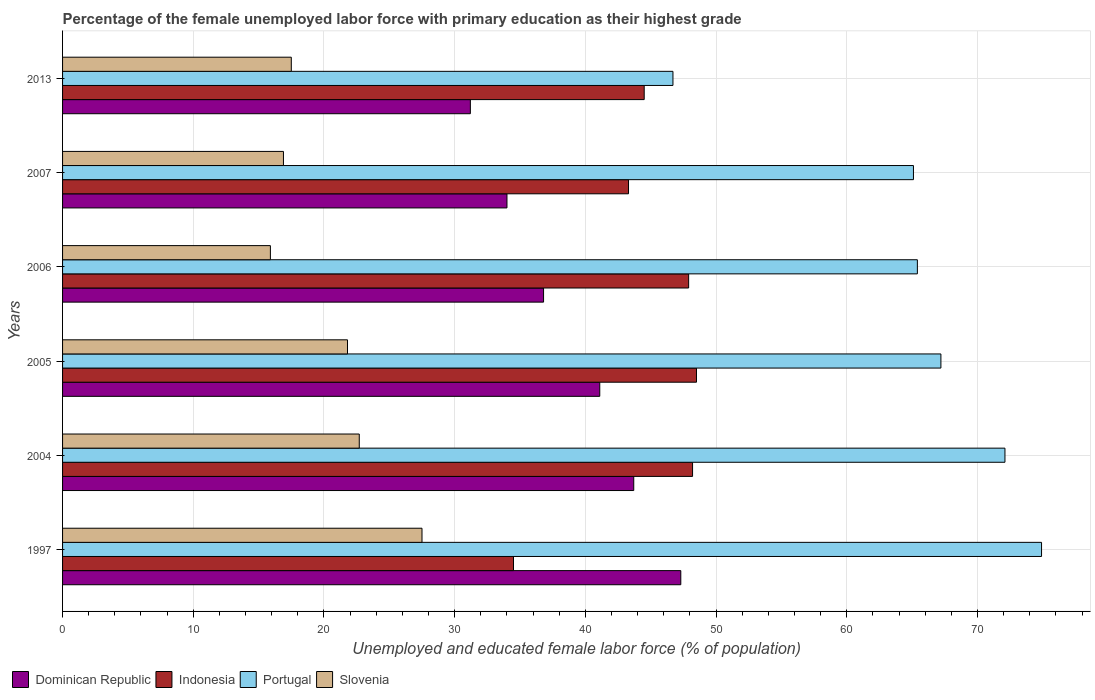How many different coloured bars are there?
Make the answer very short. 4. How many groups of bars are there?
Give a very brief answer. 6. Are the number of bars per tick equal to the number of legend labels?
Provide a short and direct response. Yes. Are the number of bars on each tick of the Y-axis equal?
Keep it short and to the point. Yes. How many bars are there on the 3rd tick from the top?
Your response must be concise. 4. What is the label of the 3rd group of bars from the top?
Provide a short and direct response. 2006. What is the percentage of the unemployed female labor force with primary education in Indonesia in 2013?
Provide a succinct answer. 44.5. Across all years, what is the maximum percentage of the unemployed female labor force with primary education in Portugal?
Provide a short and direct response. 74.9. Across all years, what is the minimum percentage of the unemployed female labor force with primary education in Dominican Republic?
Your answer should be compact. 31.2. In which year was the percentage of the unemployed female labor force with primary education in Dominican Republic maximum?
Provide a succinct answer. 1997. What is the total percentage of the unemployed female labor force with primary education in Dominican Republic in the graph?
Give a very brief answer. 234.1. What is the difference between the percentage of the unemployed female labor force with primary education in Slovenia in 2004 and that in 2005?
Give a very brief answer. 0.9. What is the difference between the percentage of the unemployed female labor force with primary education in Dominican Republic in 2013 and the percentage of the unemployed female labor force with primary education in Slovenia in 2007?
Provide a short and direct response. 14.3. What is the average percentage of the unemployed female labor force with primary education in Dominican Republic per year?
Your answer should be very brief. 39.02. In the year 2006, what is the difference between the percentage of the unemployed female labor force with primary education in Dominican Republic and percentage of the unemployed female labor force with primary education in Indonesia?
Provide a short and direct response. -11.1. What is the ratio of the percentage of the unemployed female labor force with primary education in Portugal in 2004 to that in 2013?
Provide a short and direct response. 1.54. Is the difference between the percentage of the unemployed female labor force with primary education in Dominican Republic in 2007 and 2013 greater than the difference between the percentage of the unemployed female labor force with primary education in Indonesia in 2007 and 2013?
Provide a short and direct response. Yes. What is the difference between the highest and the second highest percentage of the unemployed female labor force with primary education in Dominican Republic?
Your answer should be compact. 3.6. What is the difference between the highest and the lowest percentage of the unemployed female labor force with primary education in Dominican Republic?
Your answer should be compact. 16.1. In how many years, is the percentage of the unemployed female labor force with primary education in Indonesia greater than the average percentage of the unemployed female labor force with primary education in Indonesia taken over all years?
Make the answer very short. 4. What does the 2nd bar from the top in 1997 represents?
Provide a succinct answer. Portugal. Is it the case that in every year, the sum of the percentage of the unemployed female labor force with primary education in Dominican Republic and percentage of the unemployed female labor force with primary education in Portugal is greater than the percentage of the unemployed female labor force with primary education in Slovenia?
Your answer should be compact. Yes. How many bars are there?
Keep it short and to the point. 24. How many years are there in the graph?
Keep it short and to the point. 6. Are the values on the major ticks of X-axis written in scientific E-notation?
Offer a terse response. No. Does the graph contain grids?
Your response must be concise. Yes. How are the legend labels stacked?
Your answer should be very brief. Horizontal. What is the title of the graph?
Provide a succinct answer. Percentage of the female unemployed labor force with primary education as their highest grade. What is the label or title of the X-axis?
Offer a terse response. Unemployed and educated female labor force (% of population). What is the Unemployed and educated female labor force (% of population) in Dominican Republic in 1997?
Offer a terse response. 47.3. What is the Unemployed and educated female labor force (% of population) in Indonesia in 1997?
Provide a succinct answer. 34.5. What is the Unemployed and educated female labor force (% of population) of Portugal in 1997?
Your answer should be very brief. 74.9. What is the Unemployed and educated female labor force (% of population) of Dominican Republic in 2004?
Make the answer very short. 43.7. What is the Unemployed and educated female labor force (% of population) in Indonesia in 2004?
Offer a terse response. 48.2. What is the Unemployed and educated female labor force (% of population) in Portugal in 2004?
Offer a very short reply. 72.1. What is the Unemployed and educated female labor force (% of population) in Slovenia in 2004?
Your response must be concise. 22.7. What is the Unemployed and educated female labor force (% of population) of Dominican Republic in 2005?
Make the answer very short. 41.1. What is the Unemployed and educated female labor force (% of population) of Indonesia in 2005?
Give a very brief answer. 48.5. What is the Unemployed and educated female labor force (% of population) of Portugal in 2005?
Make the answer very short. 67.2. What is the Unemployed and educated female labor force (% of population) in Slovenia in 2005?
Give a very brief answer. 21.8. What is the Unemployed and educated female labor force (% of population) in Dominican Republic in 2006?
Provide a succinct answer. 36.8. What is the Unemployed and educated female labor force (% of population) of Indonesia in 2006?
Offer a very short reply. 47.9. What is the Unemployed and educated female labor force (% of population) of Portugal in 2006?
Provide a succinct answer. 65.4. What is the Unemployed and educated female labor force (% of population) in Slovenia in 2006?
Provide a succinct answer. 15.9. What is the Unemployed and educated female labor force (% of population) in Indonesia in 2007?
Ensure brevity in your answer.  43.3. What is the Unemployed and educated female labor force (% of population) in Portugal in 2007?
Make the answer very short. 65.1. What is the Unemployed and educated female labor force (% of population) in Slovenia in 2007?
Offer a very short reply. 16.9. What is the Unemployed and educated female labor force (% of population) of Dominican Republic in 2013?
Your answer should be very brief. 31.2. What is the Unemployed and educated female labor force (% of population) in Indonesia in 2013?
Your answer should be very brief. 44.5. What is the Unemployed and educated female labor force (% of population) of Portugal in 2013?
Keep it short and to the point. 46.7. Across all years, what is the maximum Unemployed and educated female labor force (% of population) of Dominican Republic?
Make the answer very short. 47.3. Across all years, what is the maximum Unemployed and educated female labor force (% of population) of Indonesia?
Your answer should be very brief. 48.5. Across all years, what is the maximum Unemployed and educated female labor force (% of population) in Portugal?
Provide a succinct answer. 74.9. Across all years, what is the maximum Unemployed and educated female labor force (% of population) in Slovenia?
Your answer should be very brief. 27.5. Across all years, what is the minimum Unemployed and educated female labor force (% of population) of Dominican Republic?
Offer a very short reply. 31.2. Across all years, what is the minimum Unemployed and educated female labor force (% of population) of Indonesia?
Offer a very short reply. 34.5. Across all years, what is the minimum Unemployed and educated female labor force (% of population) in Portugal?
Make the answer very short. 46.7. Across all years, what is the minimum Unemployed and educated female labor force (% of population) of Slovenia?
Ensure brevity in your answer.  15.9. What is the total Unemployed and educated female labor force (% of population) of Dominican Republic in the graph?
Provide a succinct answer. 234.1. What is the total Unemployed and educated female labor force (% of population) in Indonesia in the graph?
Your answer should be compact. 266.9. What is the total Unemployed and educated female labor force (% of population) in Portugal in the graph?
Provide a succinct answer. 391.4. What is the total Unemployed and educated female labor force (% of population) in Slovenia in the graph?
Provide a short and direct response. 122.3. What is the difference between the Unemployed and educated female labor force (% of population) in Indonesia in 1997 and that in 2004?
Your answer should be compact. -13.7. What is the difference between the Unemployed and educated female labor force (% of population) in Portugal in 1997 and that in 2004?
Provide a succinct answer. 2.8. What is the difference between the Unemployed and educated female labor force (% of population) in Slovenia in 1997 and that in 2004?
Your answer should be very brief. 4.8. What is the difference between the Unemployed and educated female labor force (% of population) in Dominican Republic in 1997 and that in 2005?
Give a very brief answer. 6.2. What is the difference between the Unemployed and educated female labor force (% of population) in Indonesia in 1997 and that in 2005?
Your response must be concise. -14. What is the difference between the Unemployed and educated female labor force (% of population) of Portugal in 1997 and that in 2005?
Provide a succinct answer. 7.7. What is the difference between the Unemployed and educated female labor force (% of population) in Slovenia in 1997 and that in 2005?
Ensure brevity in your answer.  5.7. What is the difference between the Unemployed and educated female labor force (% of population) of Indonesia in 1997 and that in 2006?
Make the answer very short. -13.4. What is the difference between the Unemployed and educated female labor force (% of population) in Portugal in 1997 and that in 2006?
Give a very brief answer. 9.5. What is the difference between the Unemployed and educated female labor force (% of population) in Dominican Republic in 1997 and that in 2007?
Offer a terse response. 13.3. What is the difference between the Unemployed and educated female labor force (% of population) of Indonesia in 1997 and that in 2013?
Make the answer very short. -10. What is the difference between the Unemployed and educated female labor force (% of population) of Portugal in 1997 and that in 2013?
Make the answer very short. 28.2. What is the difference between the Unemployed and educated female labor force (% of population) in Slovenia in 1997 and that in 2013?
Your response must be concise. 10. What is the difference between the Unemployed and educated female labor force (% of population) in Dominican Republic in 2004 and that in 2005?
Offer a very short reply. 2.6. What is the difference between the Unemployed and educated female labor force (% of population) in Indonesia in 2004 and that in 2005?
Your answer should be compact. -0.3. What is the difference between the Unemployed and educated female labor force (% of population) in Slovenia in 2004 and that in 2005?
Keep it short and to the point. 0.9. What is the difference between the Unemployed and educated female labor force (% of population) of Dominican Republic in 2004 and that in 2006?
Offer a terse response. 6.9. What is the difference between the Unemployed and educated female labor force (% of population) of Indonesia in 2004 and that in 2006?
Give a very brief answer. 0.3. What is the difference between the Unemployed and educated female labor force (% of population) of Portugal in 2004 and that in 2006?
Offer a very short reply. 6.7. What is the difference between the Unemployed and educated female labor force (% of population) of Slovenia in 2004 and that in 2006?
Ensure brevity in your answer.  6.8. What is the difference between the Unemployed and educated female labor force (% of population) of Dominican Republic in 2004 and that in 2007?
Provide a short and direct response. 9.7. What is the difference between the Unemployed and educated female labor force (% of population) of Dominican Republic in 2004 and that in 2013?
Offer a terse response. 12.5. What is the difference between the Unemployed and educated female labor force (% of population) of Portugal in 2004 and that in 2013?
Your answer should be compact. 25.4. What is the difference between the Unemployed and educated female labor force (% of population) of Slovenia in 2004 and that in 2013?
Provide a short and direct response. 5.2. What is the difference between the Unemployed and educated female labor force (% of population) of Dominican Republic in 2005 and that in 2006?
Your response must be concise. 4.3. What is the difference between the Unemployed and educated female labor force (% of population) of Portugal in 2005 and that in 2006?
Ensure brevity in your answer.  1.8. What is the difference between the Unemployed and educated female labor force (% of population) in Slovenia in 2005 and that in 2006?
Keep it short and to the point. 5.9. What is the difference between the Unemployed and educated female labor force (% of population) in Indonesia in 2005 and that in 2007?
Offer a very short reply. 5.2. What is the difference between the Unemployed and educated female labor force (% of population) in Dominican Republic in 2005 and that in 2013?
Your response must be concise. 9.9. What is the difference between the Unemployed and educated female labor force (% of population) of Indonesia in 2005 and that in 2013?
Offer a very short reply. 4. What is the difference between the Unemployed and educated female labor force (% of population) in Slovenia in 2005 and that in 2013?
Offer a very short reply. 4.3. What is the difference between the Unemployed and educated female labor force (% of population) of Dominican Republic in 2006 and that in 2007?
Offer a terse response. 2.8. What is the difference between the Unemployed and educated female labor force (% of population) of Portugal in 2006 and that in 2007?
Make the answer very short. 0.3. What is the difference between the Unemployed and educated female labor force (% of population) in Slovenia in 2006 and that in 2013?
Keep it short and to the point. -1.6. What is the difference between the Unemployed and educated female labor force (% of population) in Dominican Republic in 2007 and that in 2013?
Offer a very short reply. 2.8. What is the difference between the Unemployed and educated female labor force (% of population) in Portugal in 2007 and that in 2013?
Give a very brief answer. 18.4. What is the difference between the Unemployed and educated female labor force (% of population) of Dominican Republic in 1997 and the Unemployed and educated female labor force (% of population) of Indonesia in 2004?
Your response must be concise. -0.9. What is the difference between the Unemployed and educated female labor force (% of population) of Dominican Republic in 1997 and the Unemployed and educated female labor force (% of population) of Portugal in 2004?
Give a very brief answer. -24.8. What is the difference between the Unemployed and educated female labor force (% of population) of Dominican Republic in 1997 and the Unemployed and educated female labor force (% of population) of Slovenia in 2004?
Make the answer very short. 24.6. What is the difference between the Unemployed and educated female labor force (% of population) in Indonesia in 1997 and the Unemployed and educated female labor force (% of population) in Portugal in 2004?
Offer a very short reply. -37.6. What is the difference between the Unemployed and educated female labor force (% of population) in Portugal in 1997 and the Unemployed and educated female labor force (% of population) in Slovenia in 2004?
Your answer should be very brief. 52.2. What is the difference between the Unemployed and educated female labor force (% of population) of Dominican Republic in 1997 and the Unemployed and educated female labor force (% of population) of Portugal in 2005?
Make the answer very short. -19.9. What is the difference between the Unemployed and educated female labor force (% of population) of Dominican Republic in 1997 and the Unemployed and educated female labor force (% of population) of Slovenia in 2005?
Give a very brief answer. 25.5. What is the difference between the Unemployed and educated female labor force (% of population) of Indonesia in 1997 and the Unemployed and educated female labor force (% of population) of Portugal in 2005?
Keep it short and to the point. -32.7. What is the difference between the Unemployed and educated female labor force (% of population) of Portugal in 1997 and the Unemployed and educated female labor force (% of population) of Slovenia in 2005?
Offer a terse response. 53.1. What is the difference between the Unemployed and educated female labor force (% of population) of Dominican Republic in 1997 and the Unemployed and educated female labor force (% of population) of Portugal in 2006?
Your answer should be compact. -18.1. What is the difference between the Unemployed and educated female labor force (% of population) of Dominican Republic in 1997 and the Unemployed and educated female labor force (% of population) of Slovenia in 2006?
Make the answer very short. 31.4. What is the difference between the Unemployed and educated female labor force (% of population) in Indonesia in 1997 and the Unemployed and educated female labor force (% of population) in Portugal in 2006?
Your response must be concise. -30.9. What is the difference between the Unemployed and educated female labor force (% of population) in Portugal in 1997 and the Unemployed and educated female labor force (% of population) in Slovenia in 2006?
Offer a very short reply. 59. What is the difference between the Unemployed and educated female labor force (% of population) in Dominican Republic in 1997 and the Unemployed and educated female labor force (% of population) in Portugal in 2007?
Make the answer very short. -17.8. What is the difference between the Unemployed and educated female labor force (% of population) in Dominican Republic in 1997 and the Unemployed and educated female labor force (% of population) in Slovenia in 2007?
Keep it short and to the point. 30.4. What is the difference between the Unemployed and educated female labor force (% of population) of Indonesia in 1997 and the Unemployed and educated female labor force (% of population) of Portugal in 2007?
Make the answer very short. -30.6. What is the difference between the Unemployed and educated female labor force (% of population) in Dominican Republic in 1997 and the Unemployed and educated female labor force (% of population) in Indonesia in 2013?
Offer a very short reply. 2.8. What is the difference between the Unemployed and educated female labor force (% of population) in Dominican Republic in 1997 and the Unemployed and educated female labor force (% of population) in Slovenia in 2013?
Offer a very short reply. 29.8. What is the difference between the Unemployed and educated female labor force (% of population) in Indonesia in 1997 and the Unemployed and educated female labor force (% of population) in Portugal in 2013?
Your answer should be compact. -12.2. What is the difference between the Unemployed and educated female labor force (% of population) in Portugal in 1997 and the Unemployed and educated female labor force (% of population) in Slovenia in 2013?
Your answer should be very brief. 57.4. What is the difference between the Unemployed and educated female labor force (% of population) of Dominican Republic in 2004 and the Unemployed and educated female labor force (% of population) of Indonesia in 2005?
Keep it short and to the point. -4.8. What is the difference between the Unemployed and educated female labor force (% of population) in Dominican Republic in 2004 and the Unemployed and educated female labor force (% of population) in Portugal in 2005?
Provide a short and direct response. -23.5. What is the difference between the Unemployed and educated female labor force (% of population) in Dominican Republic in 2004 and the Unemployed and educated female labor force (% of population) in Slovenia in 2005?
Offer a very short reply. 21.9. What is the difference between the Unemployed and educated female labor force (% of population) of Indonesia in 2004 and the Unemployed and educated female labor force (% of population) of Slovenia in 2005?
Your answer should be very brief. 26.4. What is the difference between the Unemployed and educated female labor force (% of population) in Portugal in 2004 and the Unemployed and educated female labor force (% of population) in Slovenia in 2005?
Ensure brevity in your answer.  50.3. What is the difference between the Unemployed and educated female labor force (% of population) in Dominican Republic in 2004 and the Unemployed and educated female labor force (% of population) in Portugal in 2006?
Make the answer very short. -21.7. What is the difference between the Unemployed and educated female labor force (% of population) of Dominican Republic in 2004 and the Unemployed and educated female labor force (% of population) of Slovenia in 2006?
Provide a succinct answer. 27.8. What is the difference between the Unemployed and educated female labor force (% of population) in Indonesia in 2004 and the Unemployed and educated female labor force (% of population) in Portugal in 2006?
Make the answer very short. -17.2. What is the difference between the Unemployed and educated female labor force (% of population) in Indonesia in 2004 and the Unemployed and educated female labor force (% of population) in Slovenia in 2006?
Provide a short and direct response. 32.3. What is the difference between the Unemployed and educated female labor force (% of population) of Portugal in 2004 and the Unemployed and educated female labor force (% of population) of Slovenia in 2006?
Your answer should be compact. 56.2. What is the difference between the Unemployed and educated female labor force (% of population) in Dominican Republic in 2004 and the Unemployed and educated female labor force (% of population) in Portugal in 2007?
Your answer should be compact. -21.4. What is the difference between the Unemployed and educated female labor force (% of population) in Dominican Republic in 2004 and the Unemployed and educated female labor force (% of population) in Slovenia in 2007?
Your answer should be compact. 26.8. What is the difference between the Unemployed and educated female labor force (% of population) in Indonesia in 2004 and the Unemployed and educated female labor force (% of population) in Portugal in 2007?
Make the answer very short. -16.9. What is the difference between the Unemployed and educated female labor force (% of population) in Indonesia in 2004 and the Unemployed and educated female labor force (% of population) in Slovenia in 2007?
Keep it short and to the point. 31.3. What is the difference between the Unemployed and educated female labor force (% of population) of Portugal in 2004 and the Unemployed and educated female labor force (% of population) of Slovenia in 2007?
Make the answer very short. 55.2. What is the difference between the Unemployed and educated female labor force (% of population) of Dominican Republic in 2004 and the Unemployed and educated female labor force (% of population) of Slovenia in 2013?
Provide a succinct answer. 26.2. What is the difference between the Unemployed and educated female labor force (% of population) of Indonesia in 2004 and the Unemployed and educated female labor force (% of population) of Slovenia in 2013?
Make the answer very short. 30.7. What is the difference between the Unemployed and educated female labor force (% of population) in Portugal in 2004 and the Unemployed and educated female labor force (% of population) in Slovenia in 2013?
Your response must be concise. 54.6. What is the difference between the Unemployed and educated female labor force (% of population) in Dominican Republic in 2005 and the Unemployed and educated female labor force (% of population) in Indonesia in 2006?
Ensure brevity in your answer.  -6.8. What is the difference between the Unemployed and educated female labor force (% of population) in Dominican Republic in 2005 and the Unemployed and educated female labor force (% of population) in Portugal in 2006?
Offer a very short reply. -24.3. What is the difference between the Unemployed and educated female labor force (% of population) of Dominican Republic in 2005 and the Unemployed and educated female labor force (% of population) of Slovenia in 2006?
Provide a short and direct response. 25.2. What is the difference between the Unemployed and educated female labor force (% of population) of Indonesia in 2005 and the Unemployed and educated female labor force (% of population) of Portugal in 2006?
Give a very brief answer. -16.9. What is the difference between the Unemployed and educated female labor force (% of population) in Indonesia in 2005 and the Unemployed and educated female labor force (% of population) in Slovenia in 2006?
Your answer should be very brief. 32.6. What is the difference between the Unemployed and educated female labor force (% of population) in Portugal in 2005 and the Unemployed and educated female labor force (% of population) in Slovenia in 2006?
Ensure brevity in your answer.  51.3. What is the difference between the Unemployed and educated female labor force (% of population) of Dominican Republic in 2005 and the Unemployed and educated female labor force (% of population) of Portugal in 2007?
Your answer should be compact. -24. What is the difference between the Unemployed and educated female labor force (% of population) in Dominican Republic in 2005 and the Unemployed and educated female labor force (% of population) in Slovenia in 2007?
Give a very brief answer. 24.2. What is the difference between the Unemployed and educated female labor force (% of population) of Indonesia in 2005 and the Unemployed and educated female labor force (% of population) of Portugal in 2007?
Ensure brevity in your answer.  -16.6. What is the difference between the Unemployed and educated female labor force (% of population) in Indonesia in 2005 and the Unemployed and educated female labor force (% of population) in Slovenia in 2007?
Offer a very short reply. 31.6. What is the difference between the Unemployed and educated female labor force (% of population) of Portugal in 2005 and the Unemployed and educated female labor force (% of population) of Slovenia in 2007?
Give a very brief answer. 50.3. What is the difference between the Unemployed and educated female labor force (% of population) of Dominican Republic in 2005 and the Unemployed and educated female labor force (% of population) of Slovenia in 2013?
Provide a short and direct response. 23.6. What is the difference between the Unemployed and educated female labor force (% of population) of Indonesia in 2005 and the Unemployed and educated female labor force (% of population) of Portugal in 2013?
Give a very brief answer. 1.8. What is the difference between the Unemployed and educated female labor force (% of population) in Indonesia in 2005 and the Unemployed and educated female labor force (% of population) in Slovenia in 2013?
Your response must be concise. 31. What is the difference between the Unemployed and educated female labor force (% of population) of Portugal in 2005 and the Unemployed and educated female labor force (% of population) of Slovenia in 2013?
Ensure brevity in your answer.  49.7. What is the difference between the Unemployed and educated female labor force (% of population) in Dominican Republic in 2006 and the Unemployed and educated female labor force (% of population) in Portugal in 2007?
Make the answer very short. -28.3. What is the difference between the Unemployed and educated female labor force (% of population) in Indonesia in 2006 and the Unemployed and educated female labor force (% of population) in Portugal in 2007?
Make the answer very short. -17.2. What is the difference between the Unemployed and educated female labor force (% of population) in Portugal in 2006 and the Unemployed and educated female labor force (% of population) in Slovenia in 2007?
Provide a succinct answer. 48.5. What is the difference between the Unemployed and educated female labor force (% of population) of Dominican Republic in 2006 and the Unemployed and educated female labor force (% of population) of Slovenia in 2013?
Your response must be concise. 19.3. What is the difference between the Unemployed and educated female labor force (% of population) in Indonesia in 2006 and the Unemployed and educated female labor force (% of population) in Slovenia in 2013?
Give a very brief answer. 30.4. What is the difference between the Unemployed and educated female labor force (% of population) of Portugal in 2006 and the Unemployed and educated female labor force (% of population) of Slovenia in 2013?
Provide a succinct answer. 47.9. What is the difference between the Unemployed and educated female labor force (% of population) in Dominican Republic in 2007 and the Unemployed and educated female labor force (% of population) in Indonesia in 2013?
Provide a short and direct response. -10.5. What is the difference between the Unemployed and educated female labor force (% of population) of Dominican Republic in 2007 and the Unemployed and educated female labor force (% of population) of Slovenia in 2013?
Your response must be concise. 16.5. What is the difference between the Unemployed and educated female labor force (% of population) of Indonesia in 2007 and the Unemployed and educated female labor force (% of population) of Slovenia in 2013?
Make the answer very short. 25.8. What is the difference between the Unemployed and educated female labor force (% of population) of Portugal in 2007 and the Unemployed and educated female labor force (% of population) of Slovenia in 2013?
Keep it short and to the point. 47.6. What is the average Unemployed and educated female labor force (% of population) in Dominican Republic per year?
Your answer should be very brief. 39.02. What is the average Unemployed and educated female labor force (% of population) of Indonesia per year?
Give a very brief answer. 44.48. What is the average Unemployed and educated female labor force (% of population) of Portugal per year?
Offer a terse response. 65.23. What is the average Unemployed and educated female labor force (% of population) in Slovenia per year?
Your answer should be compact. 20.38. In the year 1997, what is the difference between the Unemployed and educated female labor force (% of population) of Dominican Republic and Unemployed and educated female labor force (% of population) of Portugal?
Your answer should be very brief. -27.6. In the year 1997, what is the difference between the Unemployed and educated female labor force (% of population) of Dominican Republic and Unemployed and educated female labor force (% of population) of Slovenia?
Offer a very short reply. 19.8. In the year 1997, what is the difference between the Unemployed and educated female labor force (% of population) in Indonesia and Unemployed and educated female labor force (% of population) in Portugal?
Your answer should be compact. -40.4. In the year 1997, what is the difference between the Unemployed and educated female labor force (% of population) in Portugal and Unemployed and educated female labor force (% of population) in Slovenia?
Your answer should be compact. 47.4. In the year 2004, what is the difference between the Unemployed and educated female labor force (% of population) in Dominican Republic and Unemployed and educated female labor force (% of population) in Portugal?
Offer a terse response. -28.4. In the year 2004, what is the difference between the Unemployed and educated female labor force (% of population) in Indonesia and Unemployed and educated female labor force (% of population) in Portugal?
Keep it short and to the point. -23.9. In the year 2004, what is the difference between the Unemployed and educated female labor force (% of population) of Indonesia and Unemployed and educated female labor force (% of population) of Slovenia?
Offer a terse response. 25.5. In the year 2004, what is the difference between the Unemployed and educated female labor force (% of population) in Portugal and Unemployed and educated female labor force (% of population) in Slovenia?
Provide a succinct answer. 49.4. In the year 2005, what is the difference between the Unemployed and educated female labor force (% of population) of Dominican Republic and Unemployed and educated female labor force (% of population) of Indonesia?
Make the answer very short. -7.4. In the year 2005, what is the difference between the Unemployed and educated female labor force (% of population) of Dominican Republic and Unemployed and educated female labor force (% of population) of Portugal?
Provide a short and direct response. -26.1. In the year 2005, what is the difference between the Unemployed and educated female labor force (% of population) of Dominican Republic and Unemployed and educated female labor force (% of population) of Slovenia?
Your response must be concise. 19.3. In the year 2005, what is the difference between the Unemployed and educated female labor force (% of population) of Indonesia and Unemployed and educated female labor force (% of population) of Portugal?
Give a very brief answer. -18.7. In the year 2005, what is the difference between the Unemployed and educated female labor force (% of population) in Indonesia and Unemployed and educated female labor force (% of population) in Slovenia?
Make the answer very short. 26.7. In the year 2005, what is the difference between the Unemployed and educated female labor force (% of population) of Portugal and Unemployed and educated female labor force (% of population) of Slovenia?
Provide a succinct answer. 45.4. In the year 2006, what is the difference between the Unemployed and educated female labor force (% of population) of Dominican Republic and Unemployed and educated female labor force (% of population) of Indonesia?
Keep it short and to the point. -11.1. In the year 2006, what is the difference between the Unemployed and educated female labor force (% of population) of Dominican Republic and Unemployed and educated female labor force (% of population) of Portugal?
Your answer should be compact. -28.6. In the year 2006, what is the difference between the Unemployed and educated female labor force (% of population) in Dominican Republic and Unemployed and educated female labor force (% of population) in Slovenia?
Give a very brief answer. 20.9. In the year 2006, what is the difference between the Unemployed and educated female labor force (% of population) in Indonesia and Unemployed and educated female labor force (% of population) in Portugal?
Give a very brief answer. -17.5. In the year 2006, what is the difference between the Unemployed and educated female labor force (% of population) of Indonesia and Unemployed and educated female labor force (% of population) of Slovenia?
Provide a succinct answer. 32. In the year 2006, what is the difference between the Unemployed and educated female labor force (% of population) in Portugal and Unemployed and educated female labor force (% of population) in Slovenia?
Give a very brief answer. 49.5. In the year 2007, what is the difference between the Unemployed and educated female labor force (% of population) of Dominican Republic and Unemployed and educated female labor force (% of population) of Portugal?
Ensure brevity in your answer.  -31.1. In the year 2007, what is the difference between the Unemployed and educated female labor force (% of population) of Dominican Republic and Unemployed and educated female labor force (% of population) of Slovenia?
Ensure brevity in your answer.  17.1. In the year 2007, what is the difference between the Unemployed and educated female labor force (% of population) in Indonesia and Unemployed and educated female labor force (% of population) in Portugal?
Your response must be concise. -21.8. In the year 2007, what is the difference between the Unemployed and educated female labor force (% of population) of Indonesia and Unemployed and educated female labor force (% of population) of Slovenia?
Provide a succinct answer. 26.4. In the year 2007, what is the difference between the Unemployed and educated female labor force (% of population) in Portugal and Unemployed and educated female labor force (% of population) in Slovenia?
Provide a succinct answer. 48.2. In the year 2013, what is the difference between the Unemployed and educated female labor force (% of population) of Dominican Republic and Unemployed and educated female labor force (% of population) of Portugal?
Keep it short and to the point. -15.5. In the year 2013, what is the difference between the Unemployed and educated female labor force (% of population) in Dominican Republic and Unemployed and educated female labor force (% of population) in Slovenia?
Your answer should be very brief. 13.7. In the year 2013, what is the difference between the Unemployed and educated female labor force (% of population) of Portugal and Unemployed and educated female labor force (% of population) of Slovenia?
Ensure brevity in your answer.  29.2. What is the ratio of the Unemployed and educated female labor force (% of population) of Dominican Republic in 1997 to that in 2004?
Make the answer very short. 1.08. What is the ratio of the Unemployed and educated female labor force (% of population) in Indonesia in 1997 to that in 2004?
Keep it short and to the point. 0.72. What is the ratio of the Unemployed and educated female labor force (% of population) of Portugal in 1997 to that in 2004?
Give a very brief answer. 1.04. What is the ratio of the Unemployed and educated female labor force (% of population) of Slovenia in 1997 to that in 2004?
Ensure brevity in your answer.  1.21. What is the ratio of the Unemployed and educated female labor force (% of population) in Dominican Republic in 1997 to that in 2005?
Your answer should be very brief. 1.15. What is the ratio of the Unemployed and educated female labor force (% of population) in Indonesia in 1997 to that in 2005?
Provide a succinct answer. 0.71. What is the ratio of the Unemployed and educated female labor force (% of population) of Portugal in 1997 to that in 2005?
Offer a very short reply. 1.11. What is the ratio of the Unemployed and educated female labor force (% of population) of Slovenia in 1997 to that in 2005?
Make the answer very short. 1.26. What is the ratio of the Unemployed and educated female labor force (% of population) of Dominican Republic in 1997 to that in 2006?
Your answer should be compact. 1.29. What is the ratio of the Unemployed and educated female labor force (% of population) of Indonesia in 1997 to that in 2006?
Ensure brevity in your answer.  0.72. What is the ratio of the Unemployed and educated female labor force (% of population) in Portugal in 1997 to that in 2006?
Offer a terse response. 1.15. What is the ratio of the Unemployed and educated female labor force (% of population) in Slovenia in 1997 to that in 2006?
Your answer should be compact. 1.73. What is the ratio of the Unemployed and educated female labor force (% of population) in Dominican Republic in 1997 to that in 2007?
Ensure brevity in your answer.  1.39. What is the ratio of the Unemployed and educated female labor force (% of population) of Indonesia in 1997 to that in 2007?
Your response must be concise. 0.8. What is the ratio of the Unemployed and educated female labor force (% of population) in Portugal in 1997 to that in 2007?
Your response must be concise. 1.15. What is the ratio of the Unemployed and educated female labor force (% of population) in Slovenia in 1997 to that in 2007?
Offer a very short reply. 1.63. What is the ratio of the Unemployed and educated female labor force (% of population) of Dominican Republic in 1997 to that in 2013?
Provide a short and direct response. 1.52. What is the ratio of the Unemployed and educated female labor force (% of population) in Indonesia in 1997 to that in 2013?
Your answer should be compact. 0.78. What is the ratio of the Unemployed and educated female labor force (% of population) in Portugal in 1997 to that in 2013?
Keep it short and to the point. 1.6. What is the ratio of the Unemployed and educated female labor force (% of population) of Slovenia in 1997 to that in 2013?
Your answer should be very brief. 1.57. What is the ratio of the Unemployed and educated female labor force (% of population) in Dominican Republic in 2004 to that in 2005?
Offer a terse response. 1.06. What is the ratio of the Unemployed and educated female labor force (% of population) in Portugal in 2004 to that in 2005?
Give a very brief answer. 1.07. What is the ratio of the Unemployed and educated female labor force (% of population) in Slovenia in 2004 to that in 2005?
Ensure brevity in your answer.  1.04. What is the ratio of the Unemployed and educated female labor force (% of population) in Dominican Republic in 2004 to that in 2006?
Your answer should be compact. 1.19. What is the ratio of the Unemployed and educated female labor force (% of population) of Portugal in 2004 to that in 2006?
Keep it short and to the point. 1.1. What is the ratio of the Unemployed and educated female labor force (% of population) of Slovenia in 2004 to that in 2006?
Offer a very short reply. 1.43. What is the ratio of the Unemployed and educated female labor force (% of population) of Dominican Republic in 2004 to that in 2007?
Offer a very short reply. 1.29. What is the ratio of the Unemployed and educated female labor force (% of population) of Indonesia in 2004 to that in 2007?
Offer a terse response. 1.11. What is the ratio of the Unemployed and educated female labor force (% of population) of Portugal in 2004 to that in 2007?
Your answer should be compact. 1.11. What is the ratio of the Unemployed and educated female labor force (% of population) of Slovenia in 2004 to that in 2007?
Keep it short and to the point. 1.34. What is the ratio of the Unemployed and educated female labor force (% of population) of Dominican Republic in 2004 to that in 2013?
Keep it short and to the point. 1.4. What is the ratio of the Unemployed and educated female labor force (% of population) in Indonesia in 2004 to that in 2013?
Provide a short and direct response. 1.08. What is the ratio of the Unemployed and educated female labor force (% of population) of Portugal in 2004 to that in 2013?
Your response must be concise. 1.54. What is the ratio of the Unemployed and educated female labor force (% of population) in Slovenia in 2004 to that in 2013?
Make the answer very short. 1.3. What is the ratio of the Unemployed and educated female labor force (% of population) of Dominican Republic in 2005 to that in 2006?
Keep it short and to the point. 1.12. What is the ratio of the Unemployed and educated female labor force (% of population) in Indonesia in 2005 to that in 2006?
Provide a short and direct response. 1.01. What is the ratio of the Unemployed and educated female labor force (% of population) in Portugal in 2005 to that in 2006?
Ensure brevity in your answer.  1.03. What is the ratio of the Unemployed and educated female labor force (% of population) in Slovenia in 2005 to that in 2006?
Offer a very short reply. 1.37. What is the ratio of the Unemployed and educated female labor force (% of population) in Dominican Republic in 2005 to that in 2007?
Your response must be concise. 1.21. What is the ratio of the Unemployed and educated female labor force (% of population) in Indonesia in 2005 to that in 2007?
Offer a terse response. 1.12. What is the ratio of the Unemployed and educated female labor force (% of population) of Portugal in 2005 to that in 2007?
Keep it short and to the point. 1.03. What is the ratio of the Unemployed and educated female labor force (% of population) in Slovenia in 2005 to that in 2007?
Give a very brief answer. 1.29. What is the ratio of the Unemployed and educated female labor force (% of population) of Dominican Republic in 2005 to that in 2013?
Make the answer very short. 1.32. What is the ratio of the Unemployed and educated female labor force (% of population) in Indonesia in 2005 to that in 2013?
Provide a short and direct response. 1.09. What is the ratio of the Unemployed and educated female labor force (% of population) in Portugal in 2005 to that in 2013?
Keep it short and to the point. 1.44. What is the ratio of the Unemployed and educated female labor force (% of population) in Slovenia in 2005 to that in 2013?
Keep it short and to the point. 1.25. What is the ratio of the Unemployed and educated female labor force (% of population) of Dominican Republic in 2006 to that in 2007?
Give a very brief answer. 1.08. What is the ratio of the Unemployed and educated female labor force (% of population) of Indonesia in 2006 to that in 2007?
Offer a very short reply. 1.11. What is the ratio of the Unemployed and educated female labor force (% of population) in Portugal in 2006 to that in 2007?
Make the answer very short. 1. What is the ratio of the Unemployed and educated female labor force (% of population) in Slovenia in 2006 to that in 2007?
Your response must be concise. 0.94. What is the ratio of the Unemployed and educated female labor force (% of population) in Dominican Republic in 2006 to that in 2013?
Provide a short and direct response. 1.18. What is the ratio of the Unemployed and educated female labor force (% of population) of Indonesia in 2006 to that in 2013?
Provide a short and direct response. 1.08. What is the ratio of the Unemployed and educated female labor force (% of population) of Portugal in 2006 to that in 2013?
Provide a succinct answer. 1.4. What is the ratio of the Unemployed and educated female labor force (% of population) in Slovenia in 2006 to that in 2013?
Offer a very short reply. 0.91. What is the ratio of the Unemployed and educated female labor force (% of population) of Dominican Republic in 2007 to that in 2013?
Your response must be concise. 1.09. What is the ratio of the Unemployed and educated female labor force (% of population) in Portugal in 2007 to that in 2013?
Your answer should be compact. 1.39. What is the ratio of the Unemployed and educated female labor force (% of population) in Slovenia in 2007 to that in 2013?
Give a very brief answer. 0.97. What is the difference between the highest and the second highest Unemployed and educated female labor force (% of population) in Dominican Republic?
Your answer should be compact. 3.6. What is the difference between the highest and the second highest Unemployed and educated female labor force (% of population) of Indonesia?
Make the answer very short. 0.3. What is the difference between the highest and the second highest Unemployed and educated female labor force (% of population) in Slovenia?
Keep it short and to the point. 4.8. What is the difference between the highest and the lowest Unemployed and educated female labor force (% of population) of Dominican Republic?
Your response must be concise. 16.1. What is the difference between the highest and the lowest Unemployed and educated female labor force (% of population) in Indonesia?
Keep it short and to the point. 14. What is the difference between the highest and the lowest Unemployed and educated female labor force (% of population) of Portugal?
Ensure brevity in your answer.  28.2. What is the difference between the highest and the lowest Unemployed and educated female labor force (% of population) of Slovenia?
Give a very brief answer. 11.6. 